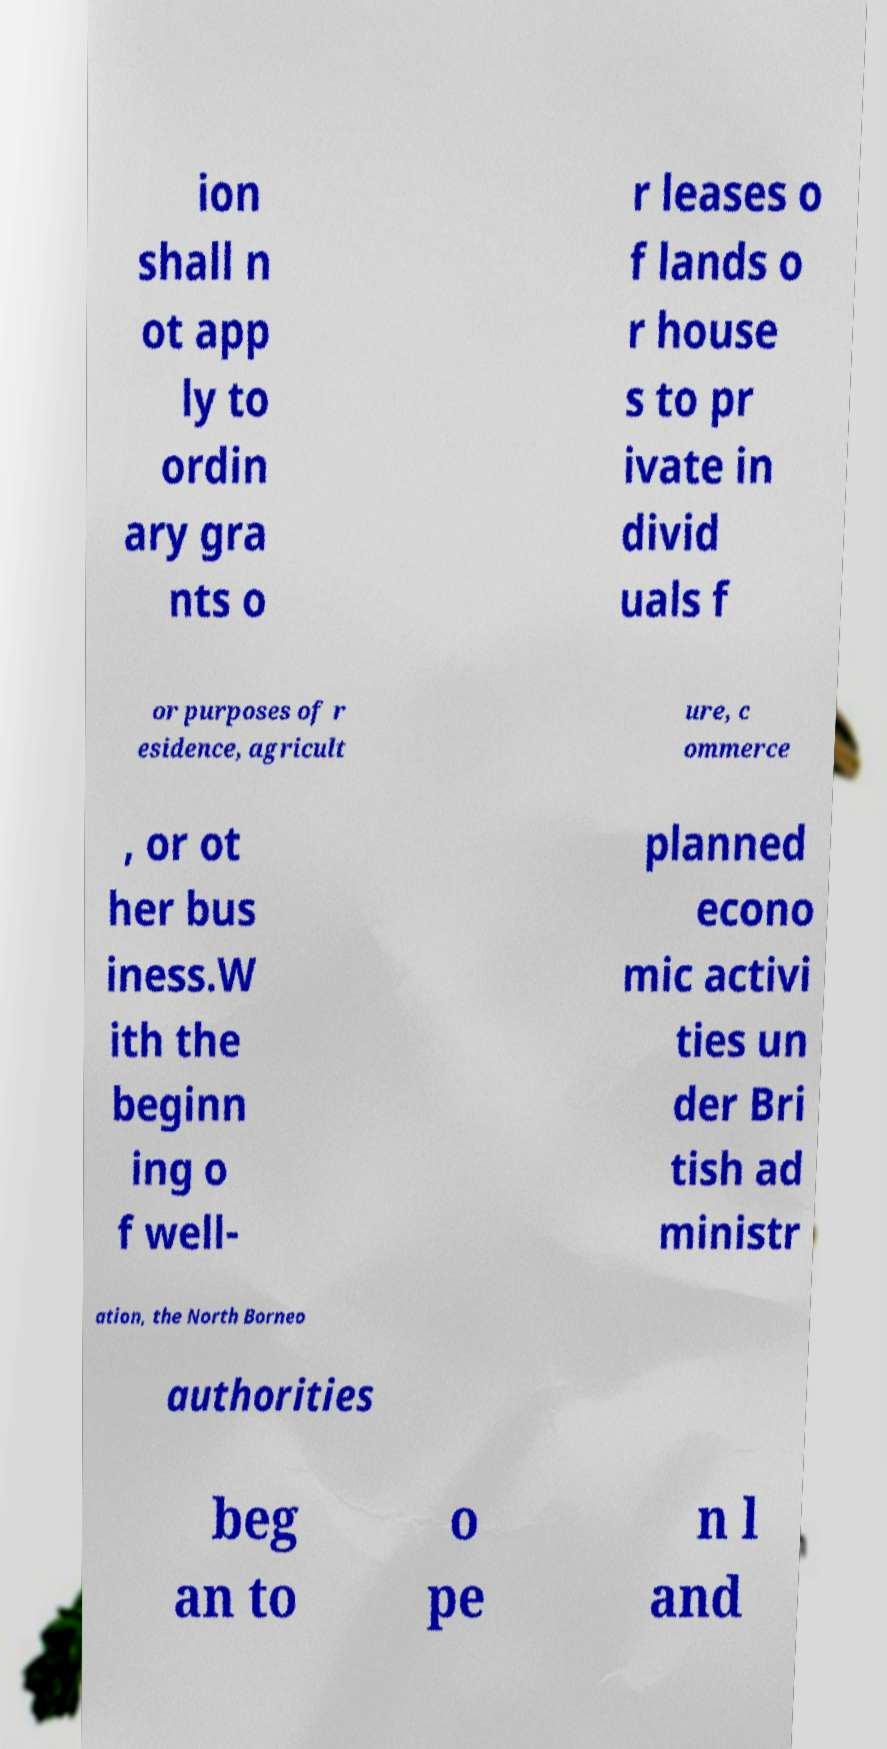Please read and relay the text visible in this image. What does it say? ion shall n ot app ly to ordin ary gra nts o r leases o f lands o r house s to pr ivate in divid uals f or purposes of r esidence, agricult ure, c ommerce , or ot her bus iness.W ith the beginn ing o f well- planned econo mic activi ties un der Bri tish ad ministr ation, the North Borneo authorities beg an to o pe n l and 